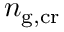Convert formula to latex. <formula><loc_0><loc_0><loc_500><loc_500>n _ { g , c r }</formula> 